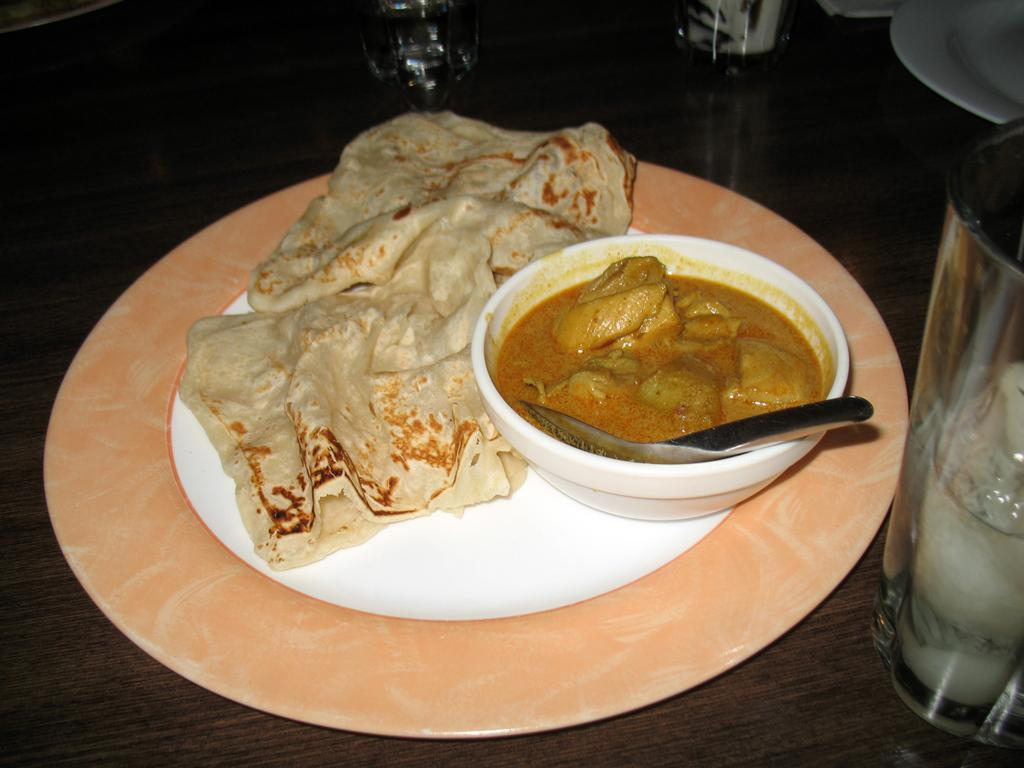What is on the plate in the image? There are food items on a plate in the image. What is in the bowl that is visible in the image? There is a bowl with a spoon in the image. What can be seen on the table in the image? There are glasses and other objects on the table in the image. What type of seed is being used to create music in the image? There is no seed or music present in the image. What time of day is it during the lunch scene in the image? The image does not specify a time of day or indicate that it is a lunch scene. 